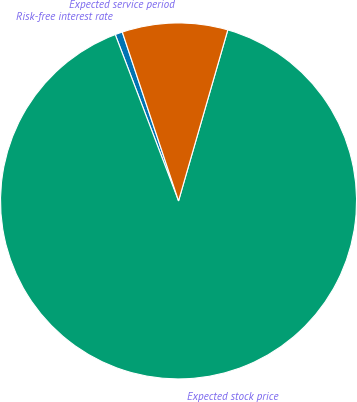<chart> <loc_0><loc_0><loc_500><loc_500><pie_chart><fcel>Risk-free interest rate<fcel>Expected stock price<fcel>Expected service period<nl><fcel>0.67%<fcel>89.75%<fcel>9.58%<nl></chart> 